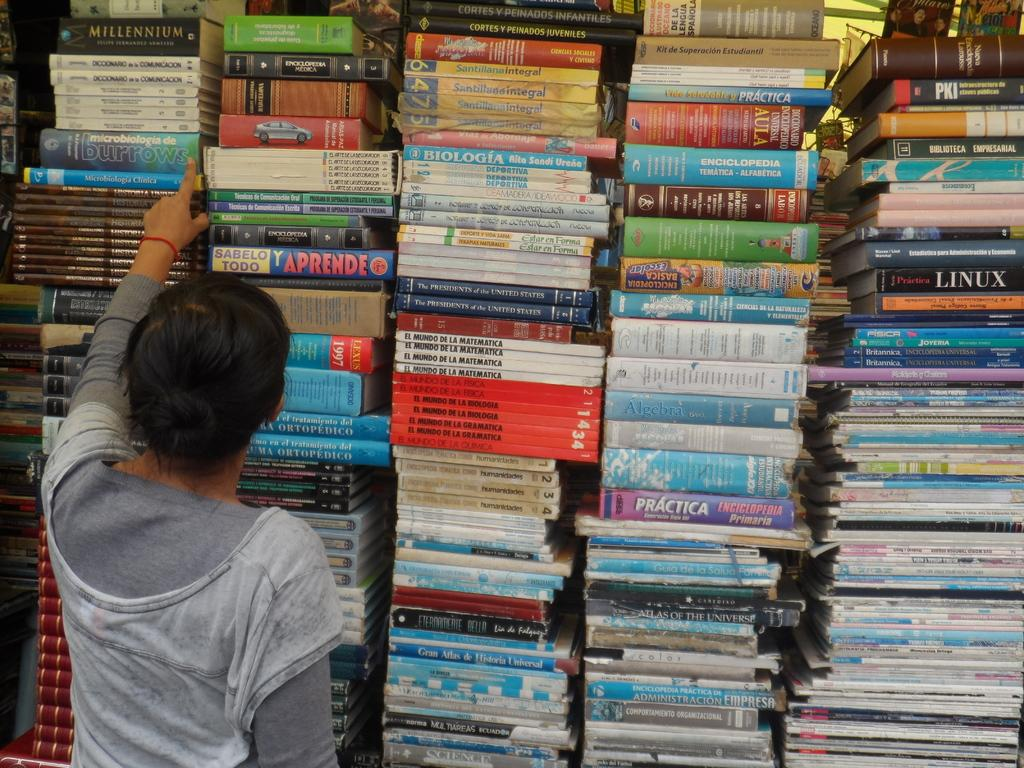<image>
Create a compact narrative representing the image presented. a person looking at some books with Linux in the pile 